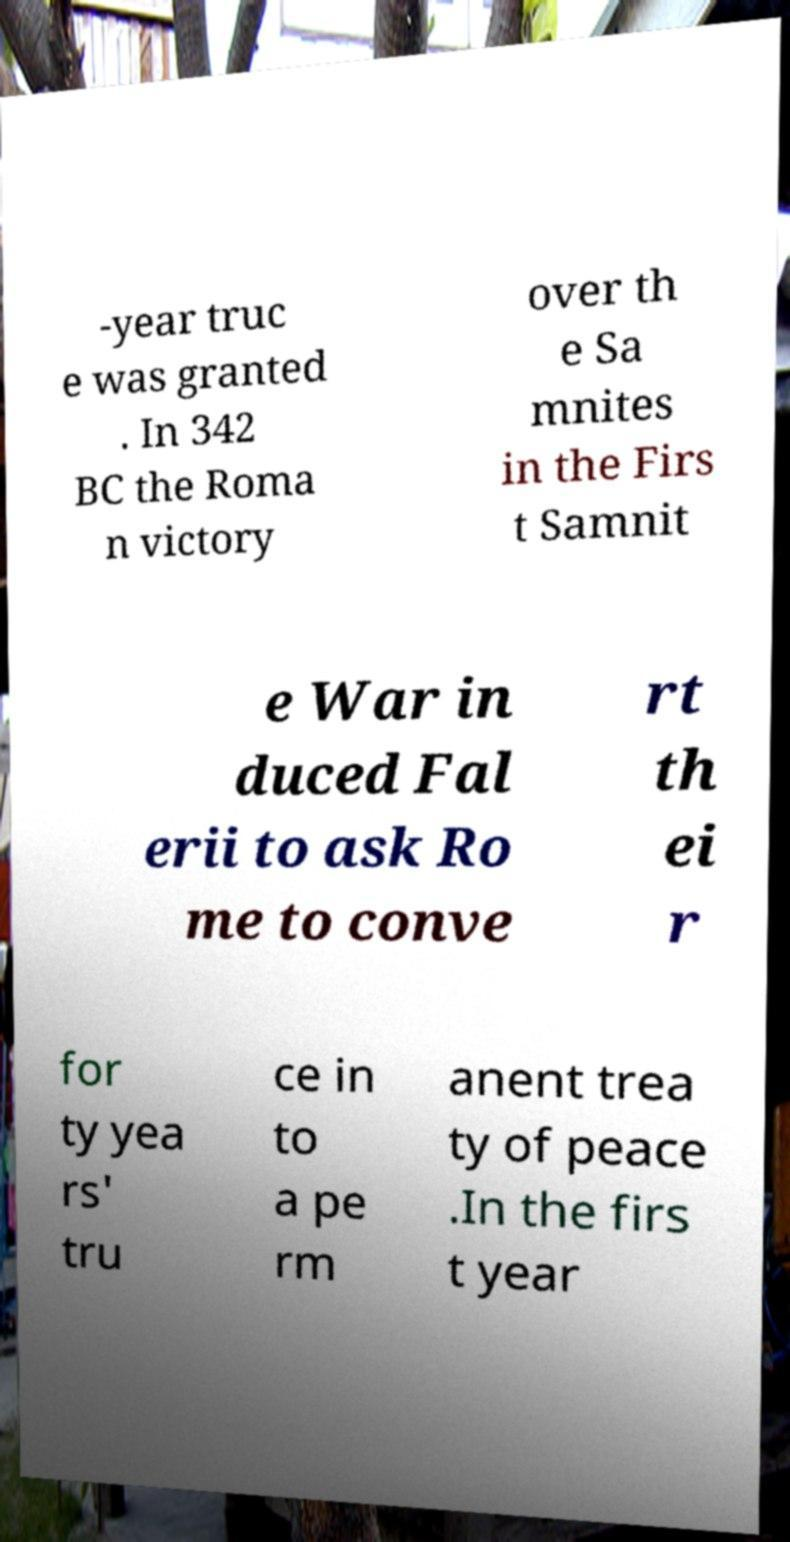Please read and relay the text visible in this image. What does it say? -year truc e was granted . In 342 BC the Roma n victory over th e Sa mnites in the Firs t Samnit e War in duced Fal erii to ask Ro me to conve rt th ei r for ty yea rs' tru ce in to a pe rm anent trea ty of peace .In the firs t year 